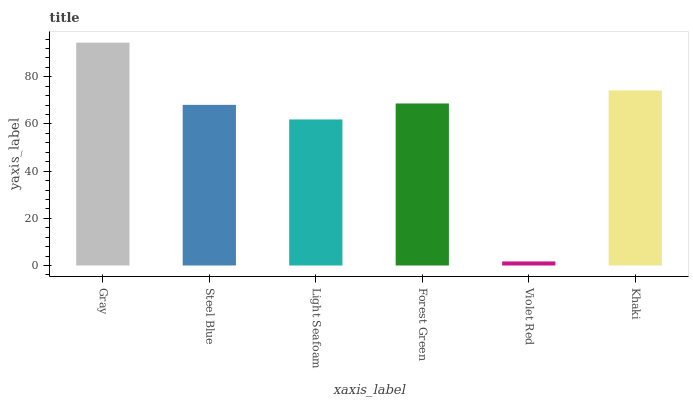Is Violet Red the minimum?
Answer yes or no. Yes. Is Gray the maximum?
Answer yes or no. Yes. Is Steel Blue the minimum?
Answer yes or no. No. Is Steel Blue the maximum?
Answer yes or no. No. Is Gray greater than Steel Blue?
Answer yes or no. Yes. Is Steel Blue less than Gray?
Answer yes or no. Yes. Is Steel Blue greater than Gray?
Answer yes or no. No. Is Gray less than Steel Blue?
Answer yes or no. No. Is Forest Green the high median?
Answer yes or no. Yes. Is Steel Blue the low median?
Answer yes or no. Yes. Is Steel Blue the high median?
Answer yes or no. No. Is Light Seafoam the low median?
Answer yes or no. No. 